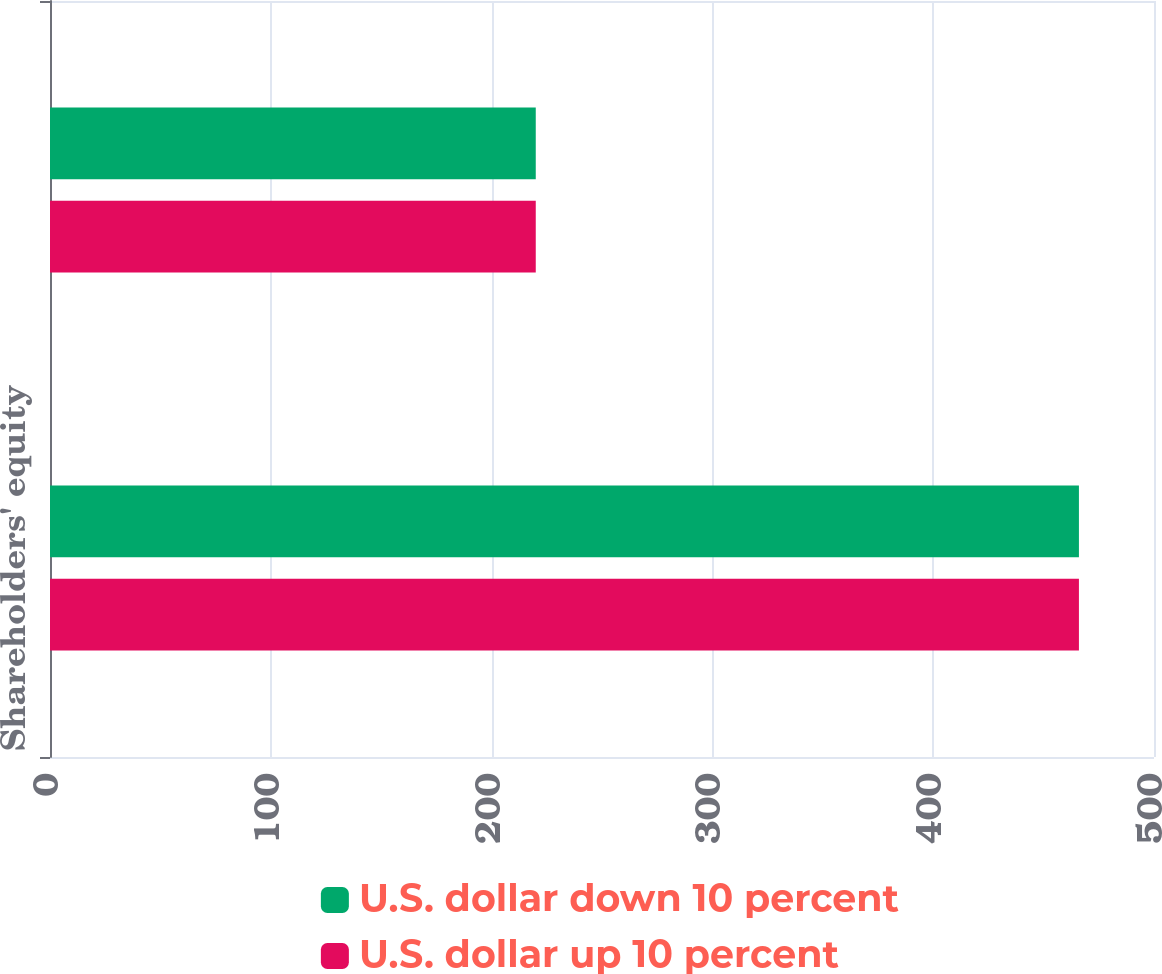<chart> <loc_0><loc_0><loc_500><loc_500><stacked_bar_chart><ecel><fcel>Shareholders' equity<fcel>Net income<nl><fcel>U.S. dollar down 10 percent<fcel>466<fcel>220<nl><fcel>U.S. dollar up 10 percent<fcel>466<fcel>220<nl></chart> 